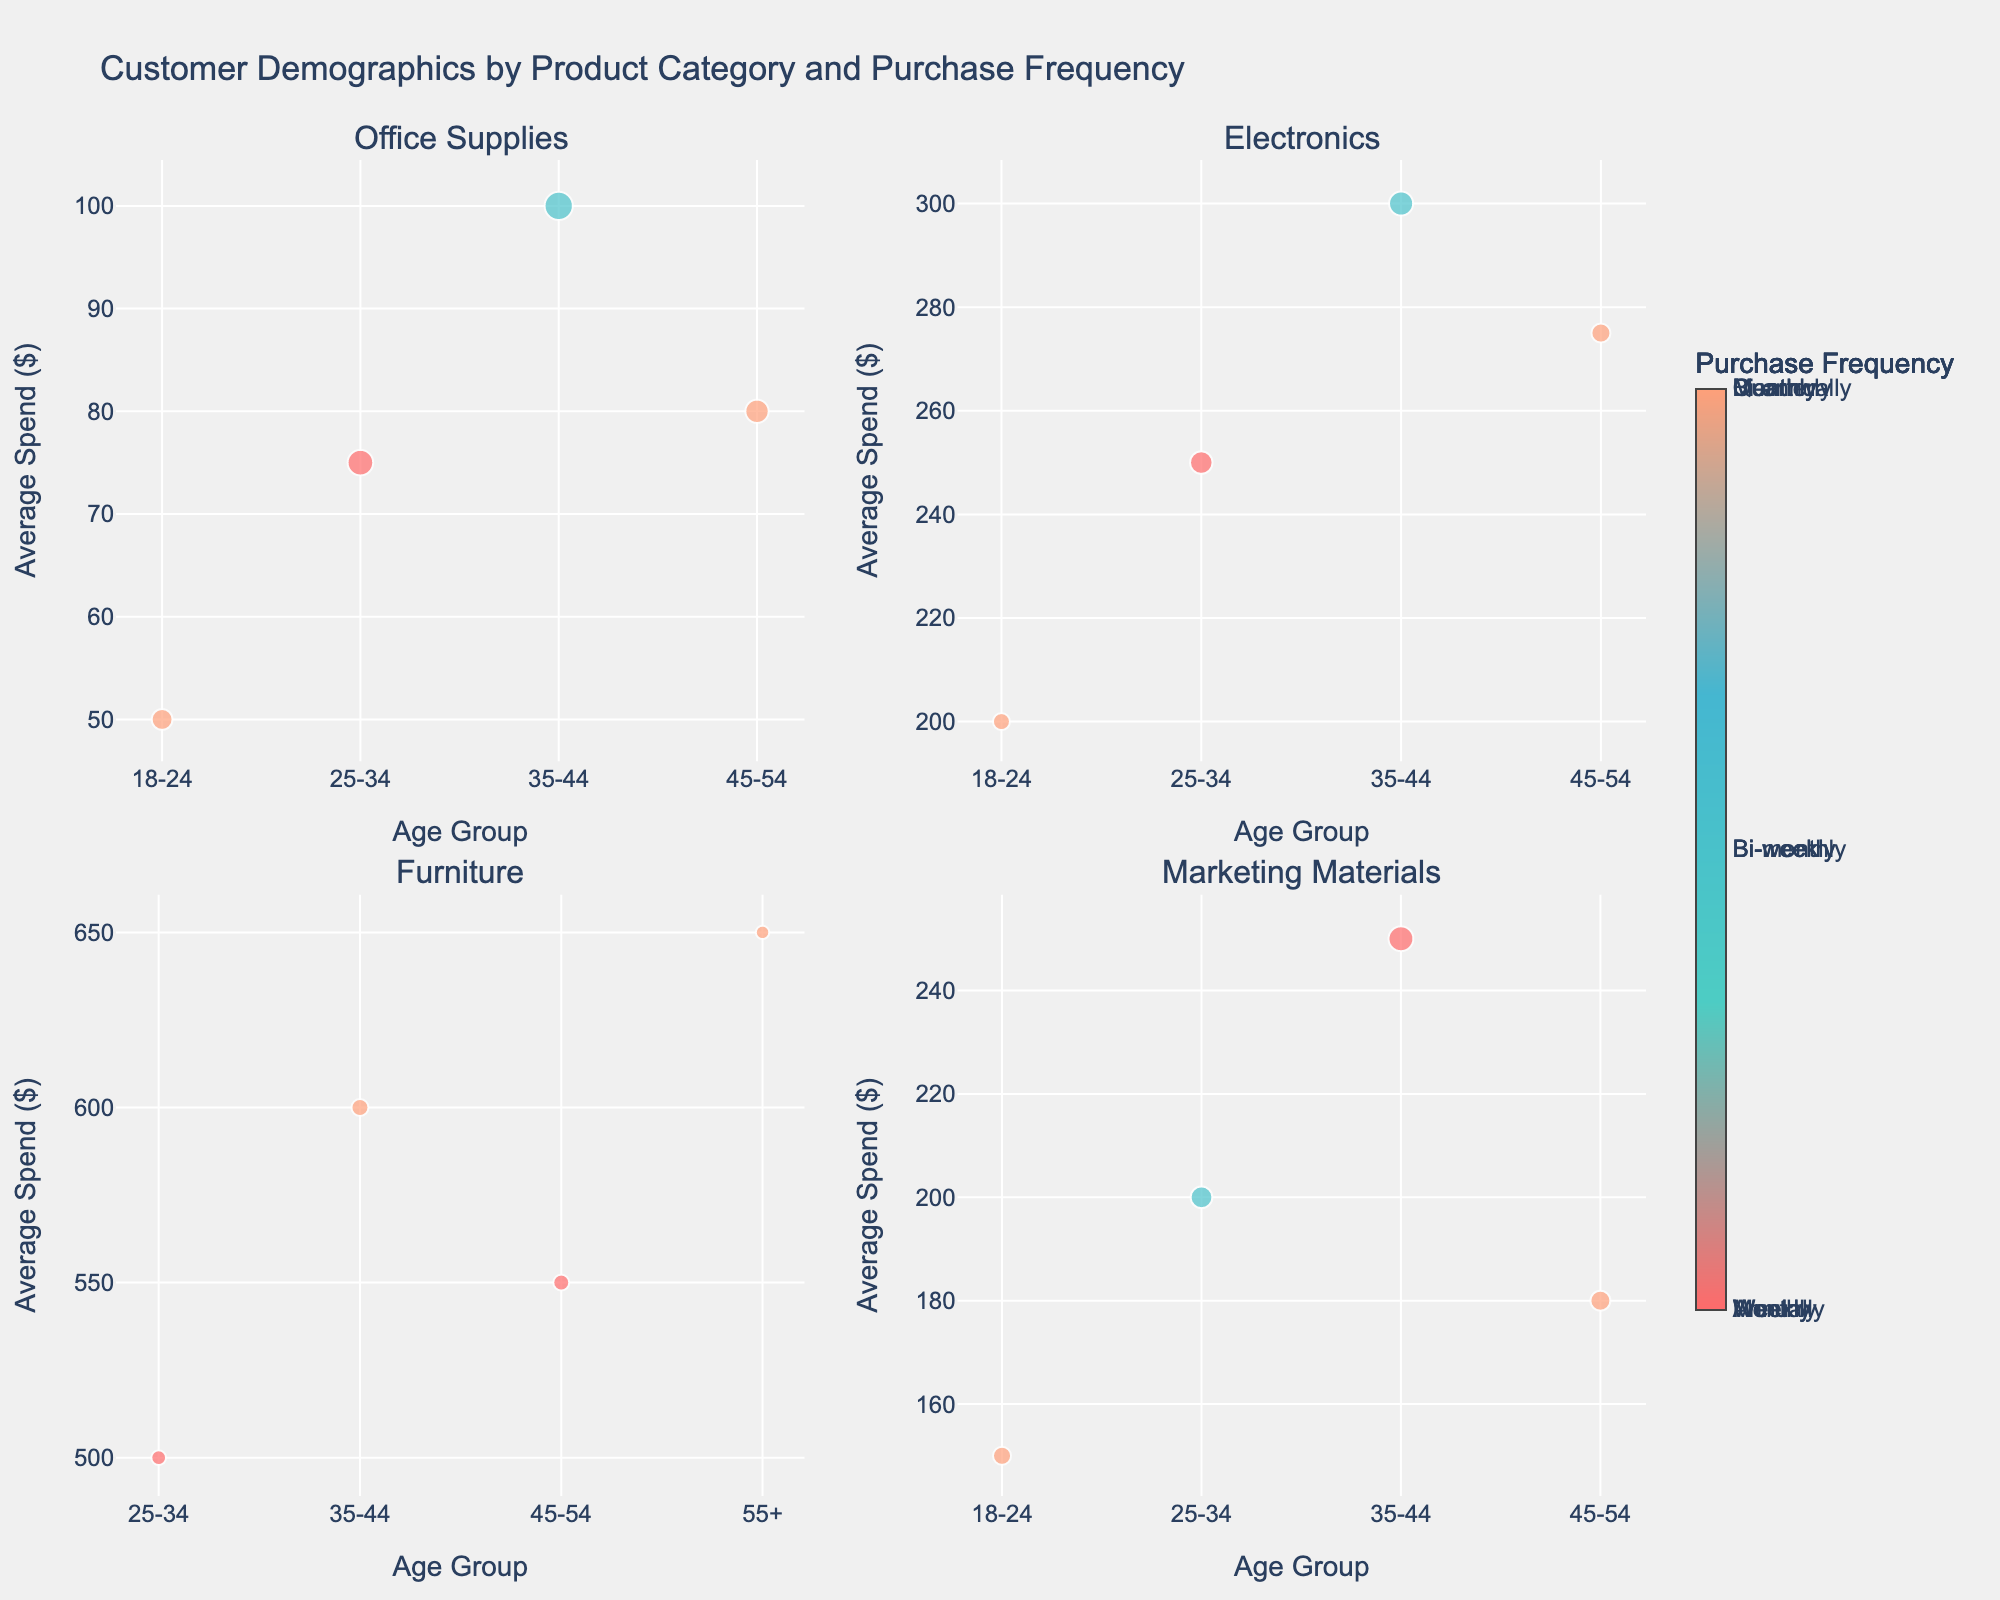How many subplots are there in the figure? The figure features three subplots, each representing plant growth under different light intensities: Low, Medium, and High.
Answer: 3 What is the title of the figure? The title is displayed at the top of the figure, describing the overall content of the chart: "Comparative Growth Rates of Plant Species Under Different Light Intensities".
Answer: Comparative Growth Rates of Plant Species Under Different Light Intensities On which day do Sunflowers reach around 22.5 cm height under high light intensity? By observing the plot for high light intensity, it is clear that Sunflowers reach around 22.5 cm on day 28.
Answer: Day 28 Which plant species shows the highest growth under medium light intensity on the 7th day? By checking the plot for medium light intensity on day 7, Sunflowers have the highest growth rate of 3.5 cm.
Answer: Sunflower What is the difference in growth of Basil under high light intensity between the 14th day and the 21st day? To find the difference, subtract the growth at day 14 from the growth at day 21 for Basil under high light intensity: 13.3 cm - 8.2 cm = 5.1 cm.
Answer: 5.1 cm Which plant grows the slowest under low light intensity at day 28? At day 28 in the low light subplot, the growth of Tomato, Basil, Lettuce, Spinach, and Sunflower can be compared, and Basil shows the slowest growth at 6.3 cm.
Answer: Basil What is the average growth of Spinach under medium light intensity over the entire period? Sum the growth values of Spinach under medium light intensity given and divide by the number of days: (0 + 3.3 + 6.9 + 11 + 15.3) / 5 = 36.5 / 5 = 7.3 cm.
Answer: 7.3 cm Is the growth trend of Tomatoes under low light intensity linear? By examining Tomato growth under low light intensity, the values increase but not by a constant amount. Hence, the trend is not linear.
Answer: No Which light intensity shows the most rapid overall growth for all plant species? Comparing the final values at day 28 for all plants under each light intensity, the high light intensity results in the highest growth for all plant species.
Answer: High Does Tomato grow faster under medium or high light intensity by day 14? Comparing Tomato growth at day 14, medium light shows 5.9 cm, while high light shows 8.8 cm. Tomato grows faster under high light intensity.
Answer: High 